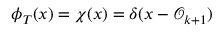Convert formula to latex. <formula><loc_0><loc_0><loc_500><loc_500>\phi _ { T } ( x ) = \chi ( x ) = \delta ( x - \mathcal { O } _ { k + 1 } )</formula> 